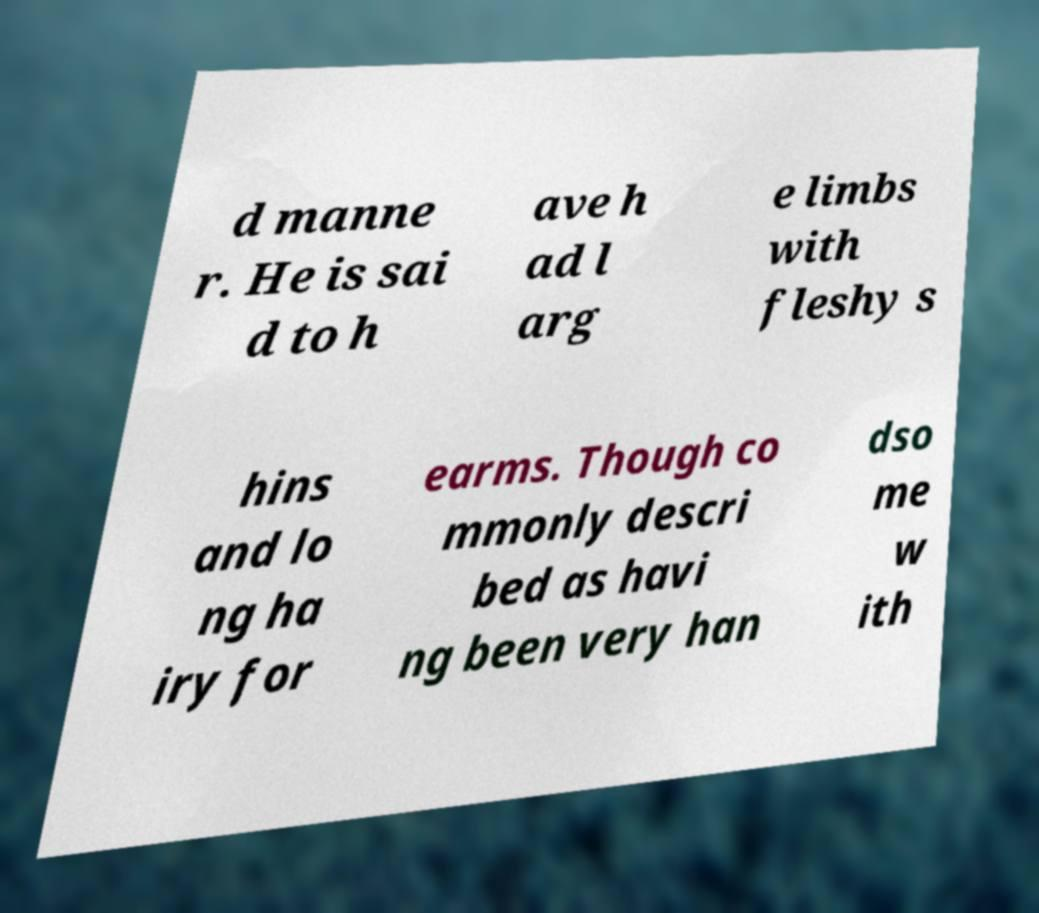For documentation purposes, I need the text within this image transcribed. Could you provide that? d manne r. He is sai d to h ave h ad l arg e limbs with fleshy s hins and lo ng ha iry for earms. Though co mmonly descri bed as havi ng been very han dso me w ith 